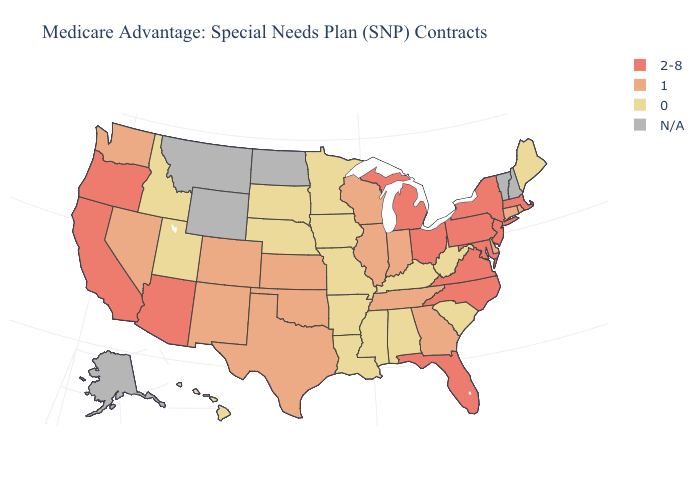What is the highest value in states that border California?
Quick response, please. 2-8. Name the states that have a value in the range N/A?
Write a very short answer. Alaska, Montana, North Dakota, New Hampshire, Vermont, Wyoming. Does Delaware have the lowest value in the USA?
Write a very short answer. No. What is the value of Vermont?
Be succinct. N/A. Does Illinois have the lowest value in the USA?
Answer briefly. No. Among the states that border Pennsylvania , does Ohio have the highest value?
Be succinct. Yes. Is the legend a continuous bar?
Answer briefly. No. Name the states that have a value in the range 1?
Quick response, please. Colorado, Connecticut, Delaware, Georgia, Illinois, Indiana, Kansas, New Mexico, Nevada, Oklahoma, Rhode Island, Tennessee, Texas, Washington, Wisconsin. Does Maryland have the highest value in the USA?
Write a very short answer. Yes. What is the lowest value in the USA?
Short answer required. 0. Name the states that have a value in the range 2-8?
Concise answer only. Arizona, California, Florida, Massachusetts, Maryland, Michigan, North Carolina, New Jersey, New York, Ohio, Oregon, Pennsylvania, Virginia. What is the value of Hawaii?
Concise answer only. 0. Does Oklahoma have the highest value in the USA?
Short answer required. No. 